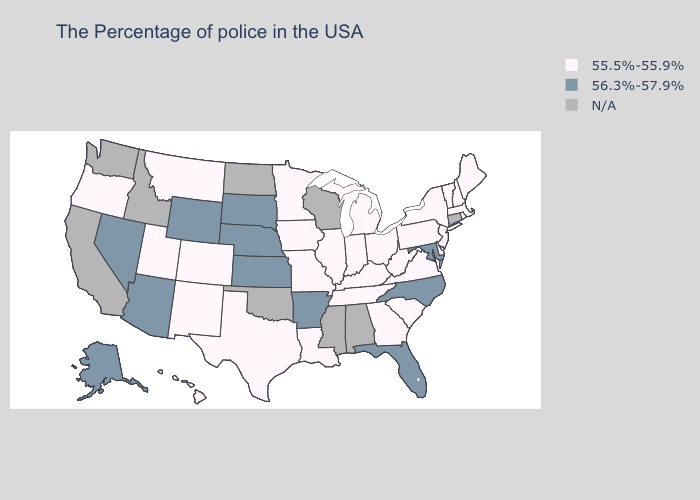Does the first symbol in the legend represent the smallest category?
Quick response, please. Yes. Does the first symbol in the legend represent the smallest category?
Concise answer only. Yes. Which states have the highest value in the USA?
Write a very short answer. Maryland, North Carolina, Florida, Arkansas, Kansas, Nebraska, South Dakota, Wyoming, Arizona, Nevada, Alaska. What is the value of North Carolina?
Be succinct. 56.3%-57.9%. Which states have the lowest value in the MidWest?
Write a very short answer. Ohio, Michigan, Indiana, Illinois, Missouri, Minnesota, Iowa. Name the states that have a value in the range 55.5%-55.9%?
Give a very brief answer. Maine, Massachusetts, Rhode Island, New Hampshire, Vermont, New York, New Jersey, Delaware, Pennsylvania, Virginia, South Carolina, West Virginia, Ohio, Georgia, Michigan, Kentucky, Indiana, Tennessee, Illinois, Louisiana, Missouri, Minnesota, Iowa, Texas, Colorado, New Mexico, Utah, Montana, Oregon, Hawaii. How many symbols are there in the legend?
Answer briefly. 3. What is the value of Louisiana?
Quick response, please. 55.5%-55.9%. What is the value of North Dakota?
Keep it brief. N/A. Among the states that border Mississippi , which have the highest value?
Answer briefly. Arkansas. Which states have the lowest value in the South?
Answer briefly. Delaware, Virginia, South Carolina, West Virginia, Georgia, Kentucky, Tennessee, Louisiana, Texas. Name the states that have a value in the range N/A?
Give a very brief answer. Connecticut, Alabama, Wisconsin, Mississippi, Oklahoma, North Dakota, Idaho, California, Washington. 